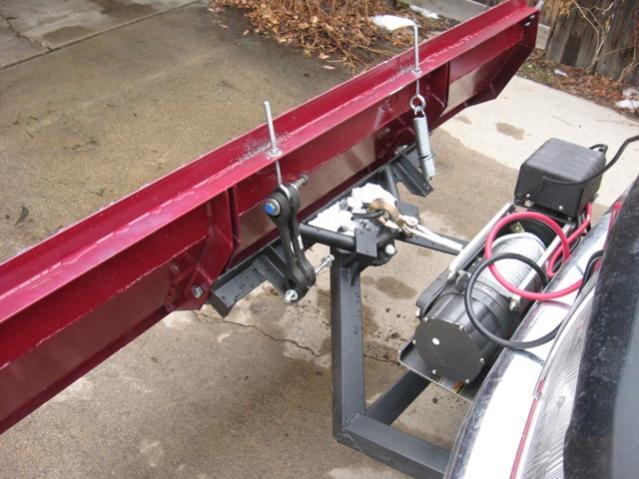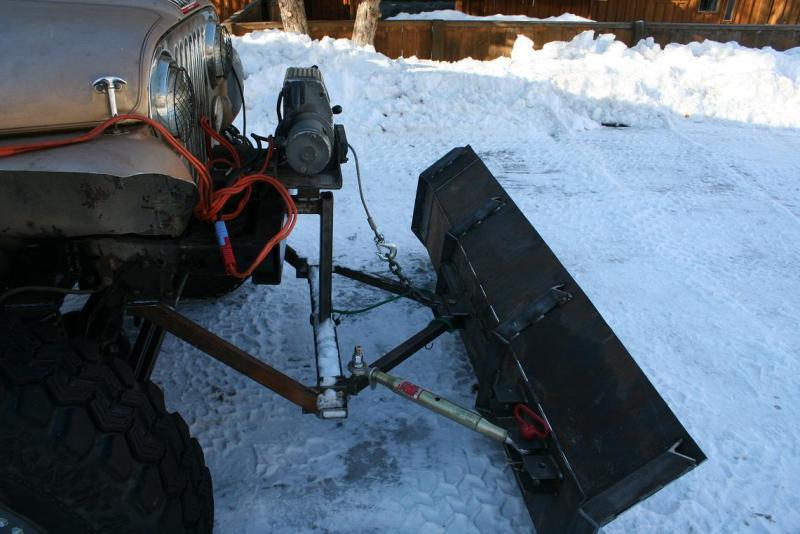The first image is the image on the left, the second image is the image on the right. Examine the images to the left and right. Is the description "An image shows an attached snow plow on a snow-covered ground." accurate? Answer yes or no. Yes. 